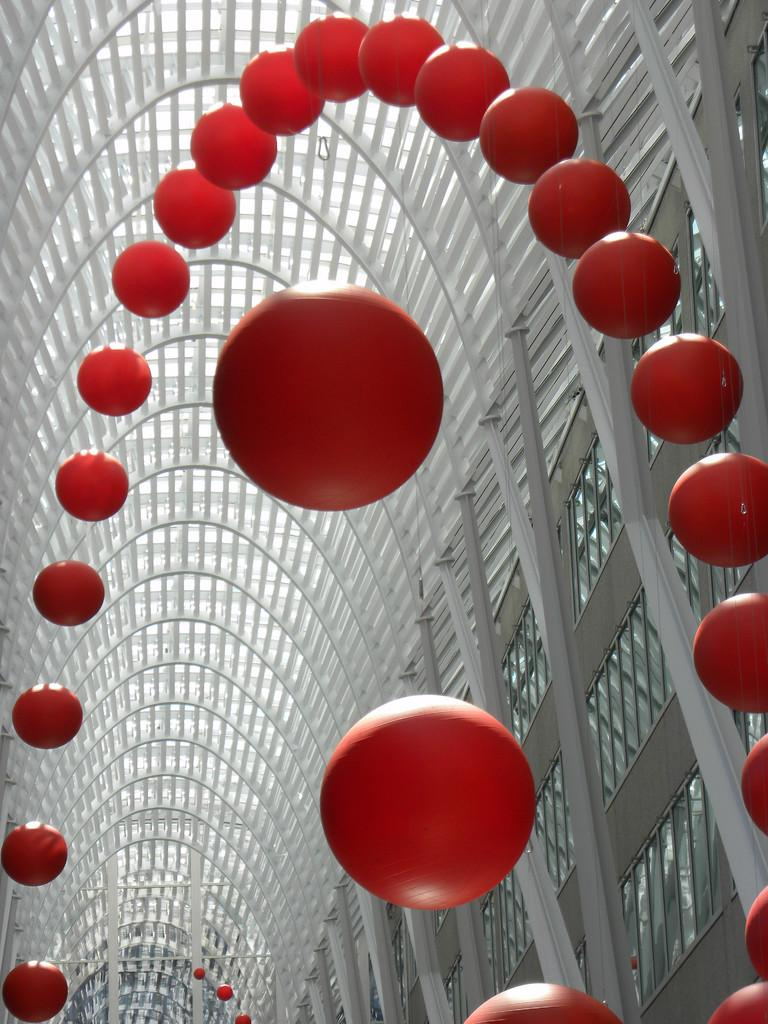What type of objects can be seen in the image? There are spherical objects in the image. What can be seen in the background of the image? There are rods and a roof visible in the background of the image. Are there any other objects present in the background of the image? Yes, there are other objects present in the background of the image. In which direction are the straws blowing in the image? There are no straws present in the image, so it is not possible to determine the direction in which they might be blowing. 